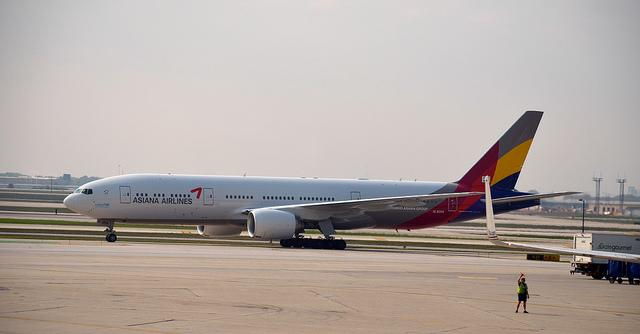Why is the man holding up an orange object? Please explain your reasoning. direct traffic. The man has an orange object so the planes can see him. 